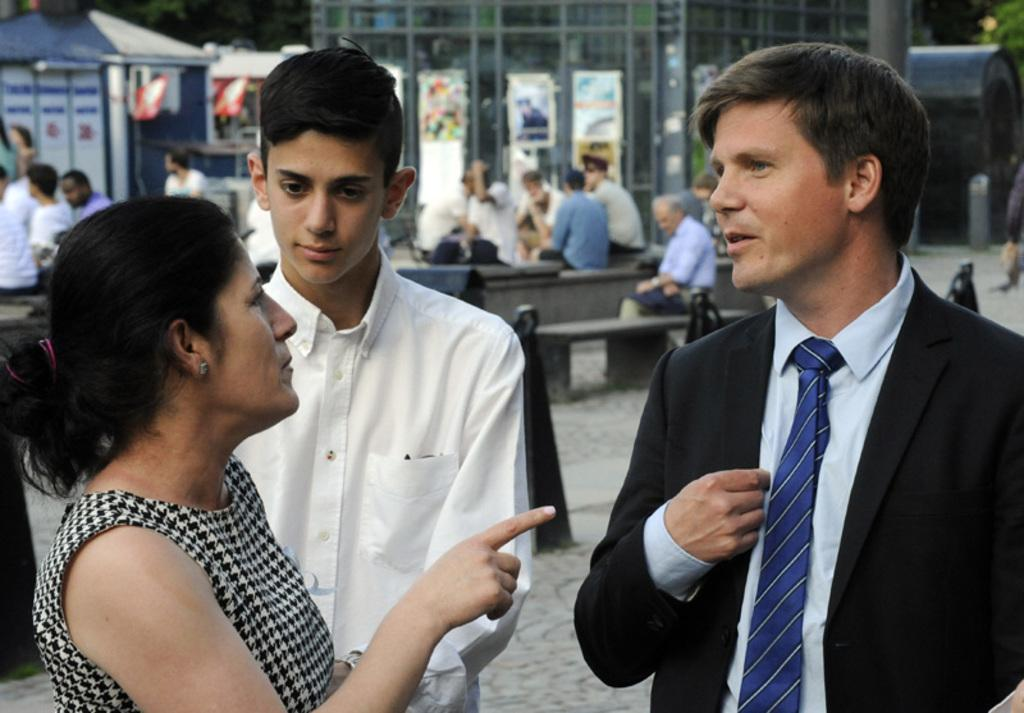How many people are in the image? There are three persons in the image. What are the people doing in the image? The people are sitting on benches in the image. What can be seen in the background of the image? There is a building, posters, and a house in the background of the image. What is the weight of the rake that is leaning against the house in the image? There is no rake present in the image, so it is not possible to determine its weight. 